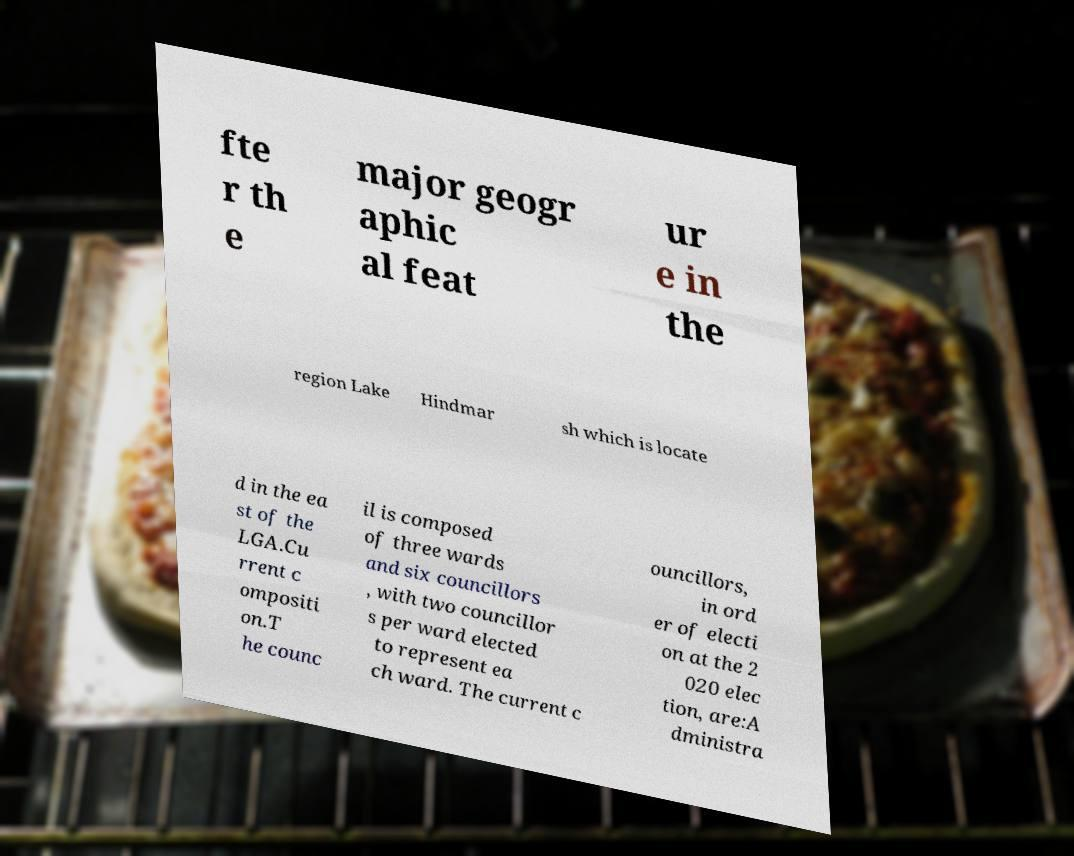Please read and relay the text visible in this image. What does it say? fte r th e major geogr aphic al feat ur e in the region Lake Hindmar sh which is locate d in the ea st of the LGA.Cu rrent c ompositi on.T he counc il is composed of three wards and six councillors , with two councillor s per ward elected to represent ea ch ward. The current c ouncillors, in ord er of electi on at the 2 020 elec tion, are:A dministra 